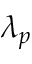Convert formula to latex. <formula><loc_0><loc_0><loc_500><loc_500>\lambda _ { p }</formula> 